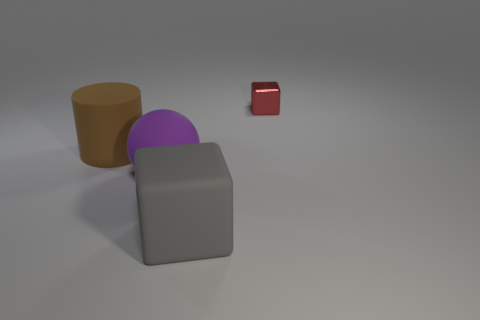Add 1 large rubber things. How many objects exist? 5 Subtract all balls. How many objects are left? 3 Subtract all rubber things. Subtract all purple matte balls. How many objects are left? 0 Add 4 gray rubber things. How many gray rubber things are left? 5 Add 3 rubber spheres. How many rubber spheres exist? 4 Subtract 0 cyan balls. How many objects are left? 4 